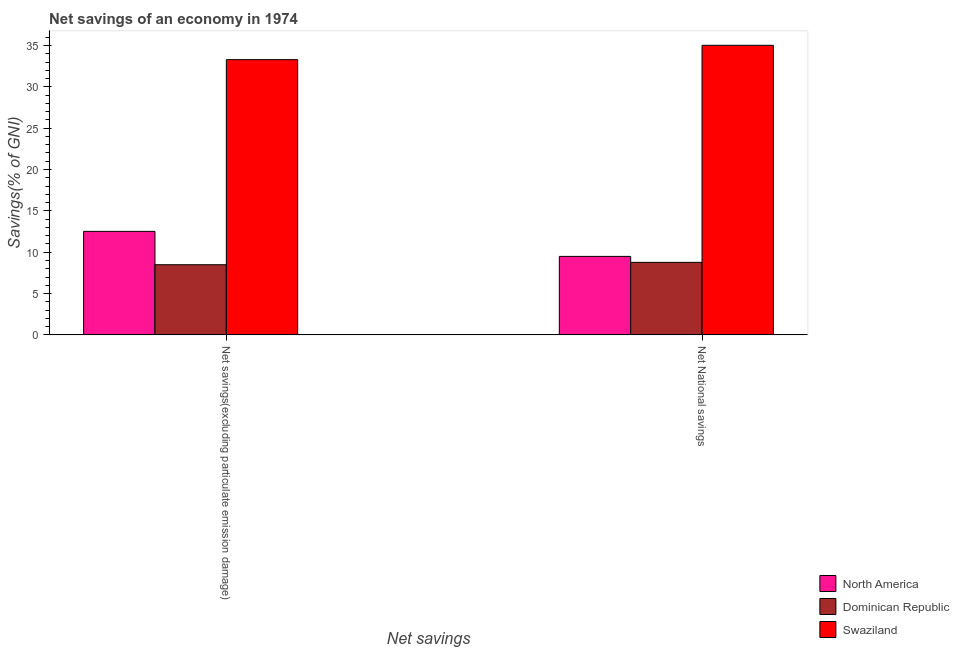How many different coloured bars are there?
Provide a short and direct response. 3. Are the number of bars per tick equal to the number of legend labels?
Ensure brevity in your answer.  Yes. How many bars are there on the 2nd tick from the left?
Offer a terse response. 3. What is the label of the 2nd group of bars from the left?
Offer a very short reply. Net National savings. What is the net savings(excluding particulate emission damage) in Swaziland?
Your answer should be very brief. 33.28. Across all countries, what is the maximum net national savings?
Your answer should be very brief. 35.02. Across all countries, what is the minimum net national savings?
Give a very brief answer. 8.77. In which country was the net savings(excluding particulate emission damage) maximum?
Offer a terse response. Swaziland. In which country was the net savings(excluding particulate emission damage) minimum?
Provide a short and direct response. Dominican Republic. What is the total net savings(excluding particulate emission damage) in the graph?
Your response must be concise. 54.29. What is the difference between the net savings(excluding particulate emission damage) in North America and that in Dominican Republic?
Provide a short and direct response. 4.03. What is the difference between the net national savings in North America and the net savings(excluding particulate emission damage) in Swaziland?
Provide a short and direct response. -23.79. What is the average net national savings per country?
Give a very brief answer. 17.76. What is the difference between the net savings(excluding particulate emission damage) and net national savings in Swaziland?
Your answer should be very brief. -1.74. What is the ratio of the net savings(excluding particulate emission damage) in Dominican Republic to that in North America?
Your answer should be compact. 0.68. Is the net savings(excluding particulate emission damage) in Dominican Republic less than that in Swaziland?
Ensure brevity in your answer.  Yes. In how many countries, is the net savings(excluding particulate emission damage) greater than the average net savings(excluding particulate emission damage) taken over all countries?
Keep it short and to the point. 1. What does the 2nd bar from the right in Net savings(excluding particulate emission damage) represents?
Keep it short and to the point. Dominican Republic. What is the difference between two consecutive major ticks on the Y-axis?
Offer a terse response. 5. Are the values on the major ticks of Y-axis written in scientific E-notation?
Your answer should be compact. No. Does the graph contain any zero values?
Offer a very short reply. No. Does the graph contain grids?
Provide a succinct answer. No. What is the title of the graph?
Ensure brevity in your answer.  Net savings of an economy in 1974. What is the label or title of the X-axis?
Offer a very short reply. Net savings. What is the label or title of the Y-axis?
Your response must be concise. Savings(% of GNI). What is the Savings(% of GNI) of North America in Net savings(excluding particulate emission damage)?
Provide a succinct answer. 12.52. What is the Savings(% of GNI) of Dominican Republic in Net savings(excluding particulate emission damage)?
Offer a terse response. 8.48. What is the Savings(% of GNI) of Swaziland in Net savings(excluding particulate emission damage)?
Your answer should be very brief. 33.28. What is the Savings(% of GNI) in North America in Net National savings?
Your answer should be compact. 9.49. What is the Savings(% of GNI) of Dominican Republic in Net National savings?
Your response must be concise. 8.77. What is the Savings(% of GNI) of Swaziland in Net National savings?
Provide a succinct answer. 35.02. Across all Net savings, what is the maximum Savings(% of GNI) of North America?
Provide a short and direct response. 12.52. Across all Net savings, what is the maximum Savings(% of GNI) in Dominican Republic?
Provide a succinct answer. 8.77. Across all Net savings, what is the maximum Savings(% of GNI) of Swaziland?
Make the answer very short. 35.02. Across all Net savings, what is the minimum Savings(% of GNI) of North America?
Keep it short and to the point. 9.49. Across all Net savings, what is the minimum Savings(% of GNI) of Dominican Republic?
Your answer should be compact. 8.48. Across all Net savings, what is the minimum Savings(% of GNI) of Swaziland?
Your answer should be very brief. 33.28. What is the total Savings(% of GNI) in North America in the graph?
Offer a terse response. 22.01. What is the total Savings(% of GNI) in Dominican Republic in the graph?
Keep it short and to the point. 17.26. What is the total Savings(% of GNI) of Swaziland in the graph?
Ensure brevity in your answer.  68.3. What is the difference between the Savings(% of GNI) of North America in Net savings(excluding particulate emission damage) and that in Net National savings?
Ensure brevity in your answer.  3.03. What is the difference between the Savings(% of GNI) in Dominican Republic in Net savings(excluding particulate emission damage) and that in Net National savings?
Make the answer very short. -0.29. What is the difference between the Savings(% of GNI) in Swaziland in Net savings(excluding particulate emission damage) and that in Net National savings?
Ensure brevity in your answer.  -1.74. What is the difference between the Savings(% of GNI) in North America in Net savings(excluding particulate emission damage) and the Savings(% of GNI) in Dominican Republic in Net National savings?
Provide a succinct answer. 3.75. What is the difference between the Savings(% of GNI) in North America in Net savings(excluding particulate emission damage) and the Savings(% of GNI) in Swaziland in Net National savings?
Ensure brevity in your answer.  -22.5. What is the difference between the Savings(% of GNI) in Dominican Republic in Net savings(excluding particulate emission damage) and the Savings(% of GNI) in Swaziland in Net National savings?
Your answer should be very brief. -26.53. What is the average Savings(% of GNI) of North America per Net savings?
Offer a terse response. 11.01. What is the average Savings(% of GNI) of Dominican Republic per Net savings?
Ensure brevity in your answer.  8.63. What is the average Savings(% of GNI) of Swaziland per Net savings?
Give a very brief answer. 34.15. What is the difference between the Savings(% of GNI) in North America and Savings(% of GNI) in Dominican Republic in Net savings(excluding particulate emission damage)?
Your response must be concise. 4.03. What is the difference between the Savings(% of GNI) of North America and Savings(% of GNI) of Swaziland in Net savings(excluding particulate emission damage)?
Provide a short and direct response. -20.76. What is the difference between the Savings(% of GNI) of Dominican Republic and Savings(% of GNI) of Swaziland in Net savings(excluding particulate emission damage)?
Your answer should be very brief. -24.8. What is the difference between the Savings(% of GNI) in North America and Savings(% of GNI) in Dominican Republic in Net National savings?
Give a very brief answer. 0.72. What is the difference between the Savings(% of GNI) in North America and Savings(% of GNI) in Swaziland in Net National savings?
Your answer should be very brief. -25.53. What is the difference between the Savings(% of GNI) of Dominican Republic and Savings(% of GNI) of Swaziland in Net National savings?
Make the answer very short. -26.25. What is the ratio of the Savings(% of GNI) in North America in Net savings(excluding particulate emission damage) to that in Net National savings?
Your response must be concise. 1.32. What is the ratio of the Savings(% of GNI) of Dominican Republic in Net savings(excluding particulate emission damage) to that in Net National savings?
Ensure brevity in your answer.  0.97. What is the ratio of the Savings(% of GNI) of Swaziland in Net savings(excluding particulate emission damage) to that in Net National savings?
Your answer should be very brief. 0.95. What is the difference between the highest and the second highest Savings(% of GNI) in North America?
Offer a terse response. 3.03. What is the difference between the highest and the second highest Savings(% of GNI) in Dominican Republic?
Provide a succinct answer. 0.29. What is the difference between the highest and the second highest Savings(% of GNI) in Swaziland?
Make the answer very short. 1.74. What is the difference between the highest and the lowest Savings(% of GNI) in North America?
Make the answer very short. 3.03. What is the difference between the highest and the lowest Savings(% of GNI) in Dominican Republic?
Give a very brief answer. 0.29. What is the difference between the highest and the lowest Savings(% of GNI) of Swaziland?
Provide a succinct answer. 1.74. 